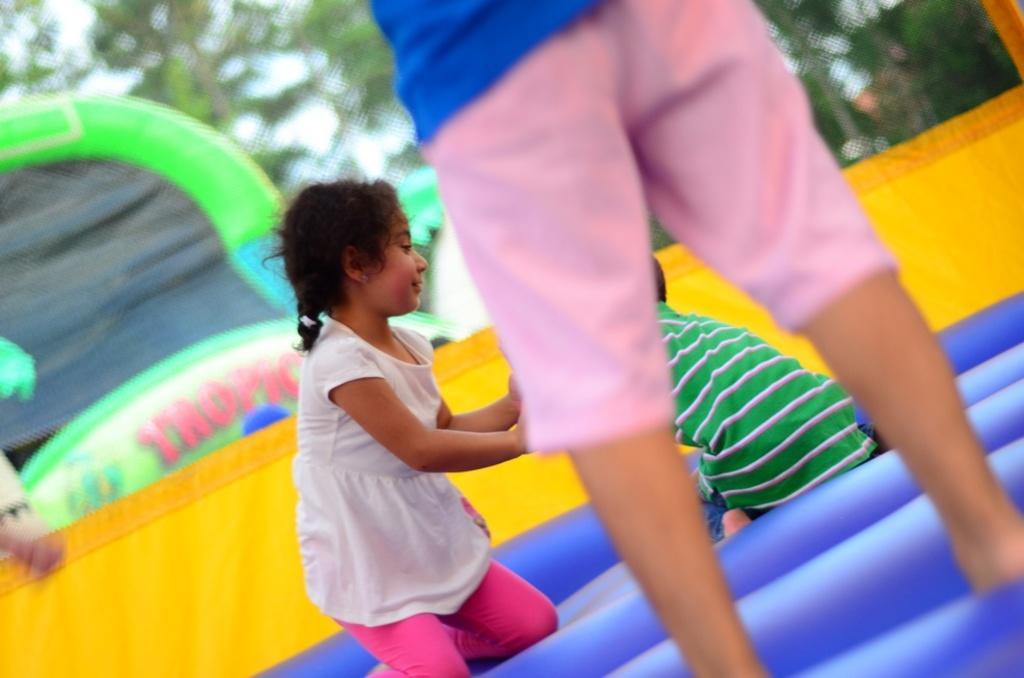Can you describe this image briefly? In this picture we can see group of people, they are playing on the inflatable, in the background we can see few trees. 